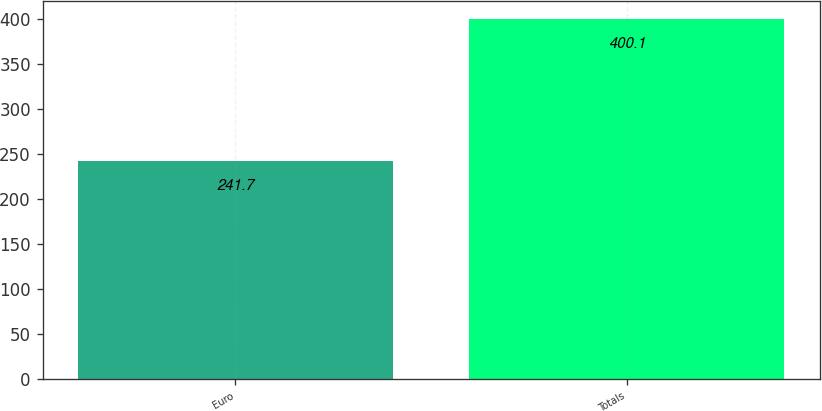Convert chart to OTSL. <chart><loc_0><loc_0><loc_500><loc_500><bar_chart><fcel>Euro<fcel>Totals<nl><fcel>241.7<fcel>400.1<nl></chart> 